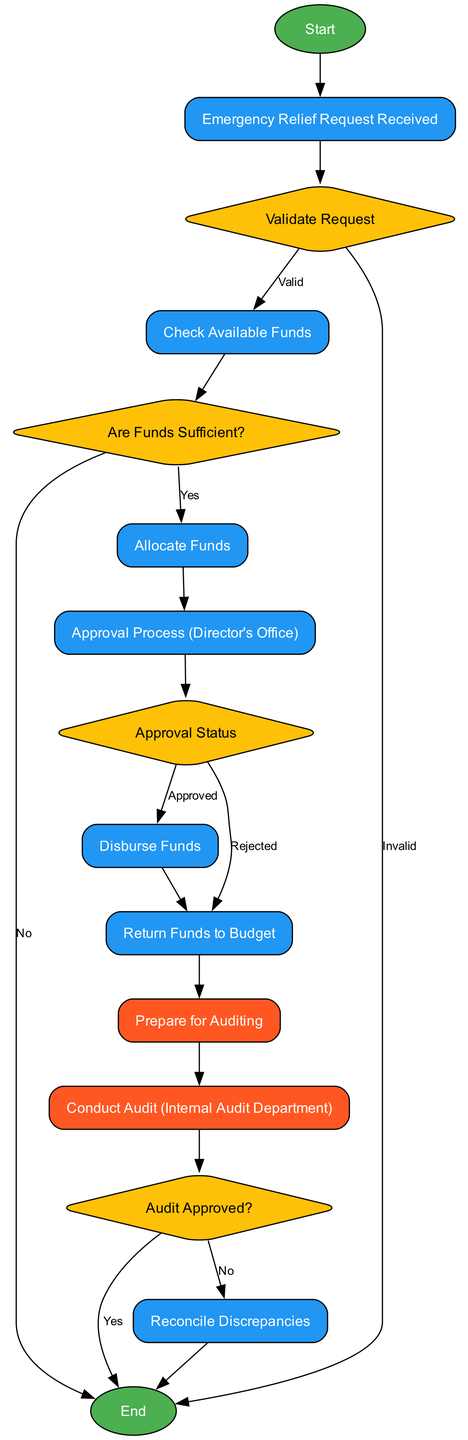What is the first step in the Emergency Relief Fund Allocation Process? The first step in the process is the "Start" node, which indicates the initiation of the allocation process.
Answer: Start How many decision nodes are present in the diagram? There are four decision nodes in the diagram: "Validate Request," "Are Funds Sufficient?," "Approval Status," and "Audit Approved?"
Answer: 4 What happens if the emergency relief request is invalid? If the emergency relief request is invalid, the flowchart indicates that the process ends, moving directly to the "End" node without further steps.
Answer: End What step comes after the "Approval Process (Director's Office)"? After the "Approval Process (Director's Office)," the next step is the "Approval Status" decision node, where the status of the approval is determined.
Answer: Approval Status If funds are allocated successfully, what is the next process? If funds are allocated successfully, the next process is to undergo the "Approval Process (Director's Office)" to seek formal approval from the director's office.
Answer: Approval Process (Director's Office) What are the two possible outcomes of the "Audit Approved?" decision node? The two possible outcomes of the "Audit Approved?" decision node are "yes" leading to the "End" and "no" leading to the "Reconcile Discrepancies" process.
Answer: Yes and No If funds are insufficient, what is the resulting action in the flowchart? If funds are insufficient, the flowchart directs the process to "End," which means no funds can be allocated for the emergency relief request.
Answer: End What process follows the "Disburse Funds" step? Following the "Disburse Funds" step, the next process is to "Prepare for Auditing," where readiness for audit takes place after fund disbursement.
Answer: Prepare for Auditing What action is taken if the approval status is rejected? If the approval status is rejected, the action taken is to "Return Funds to Budget," which indicates the rejection of the request leads to fund recovery.
Answer: Return Funds to Budget 